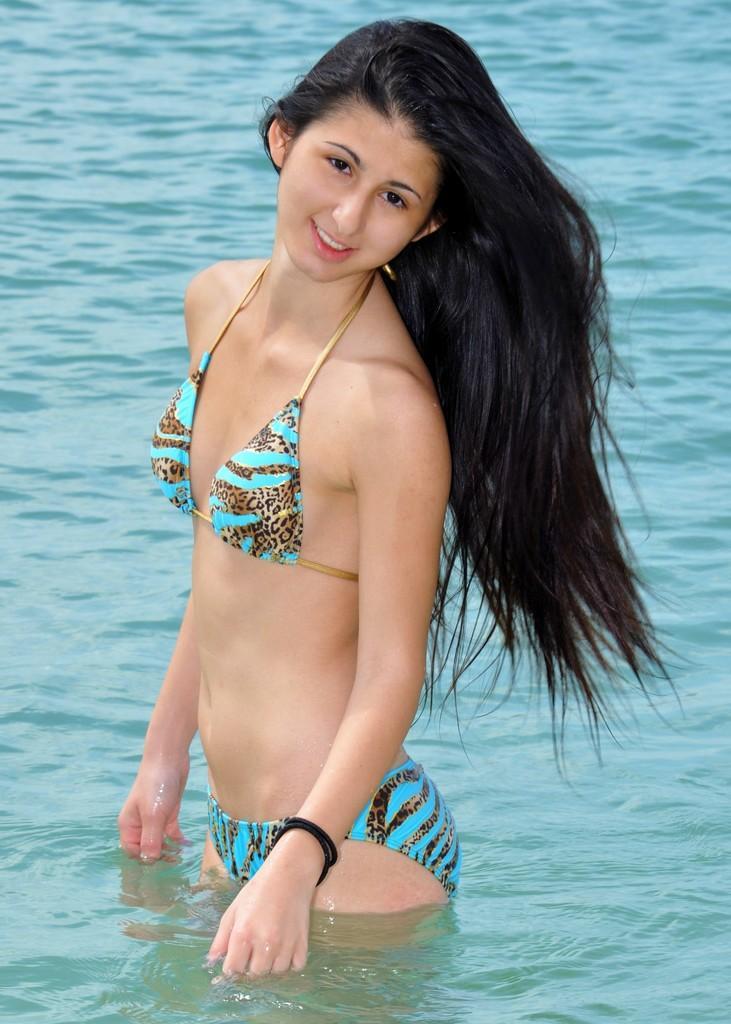In one or two sentences, can you explain what this image depicts? In the middle of the image a woman is standing in the water and smiling. 